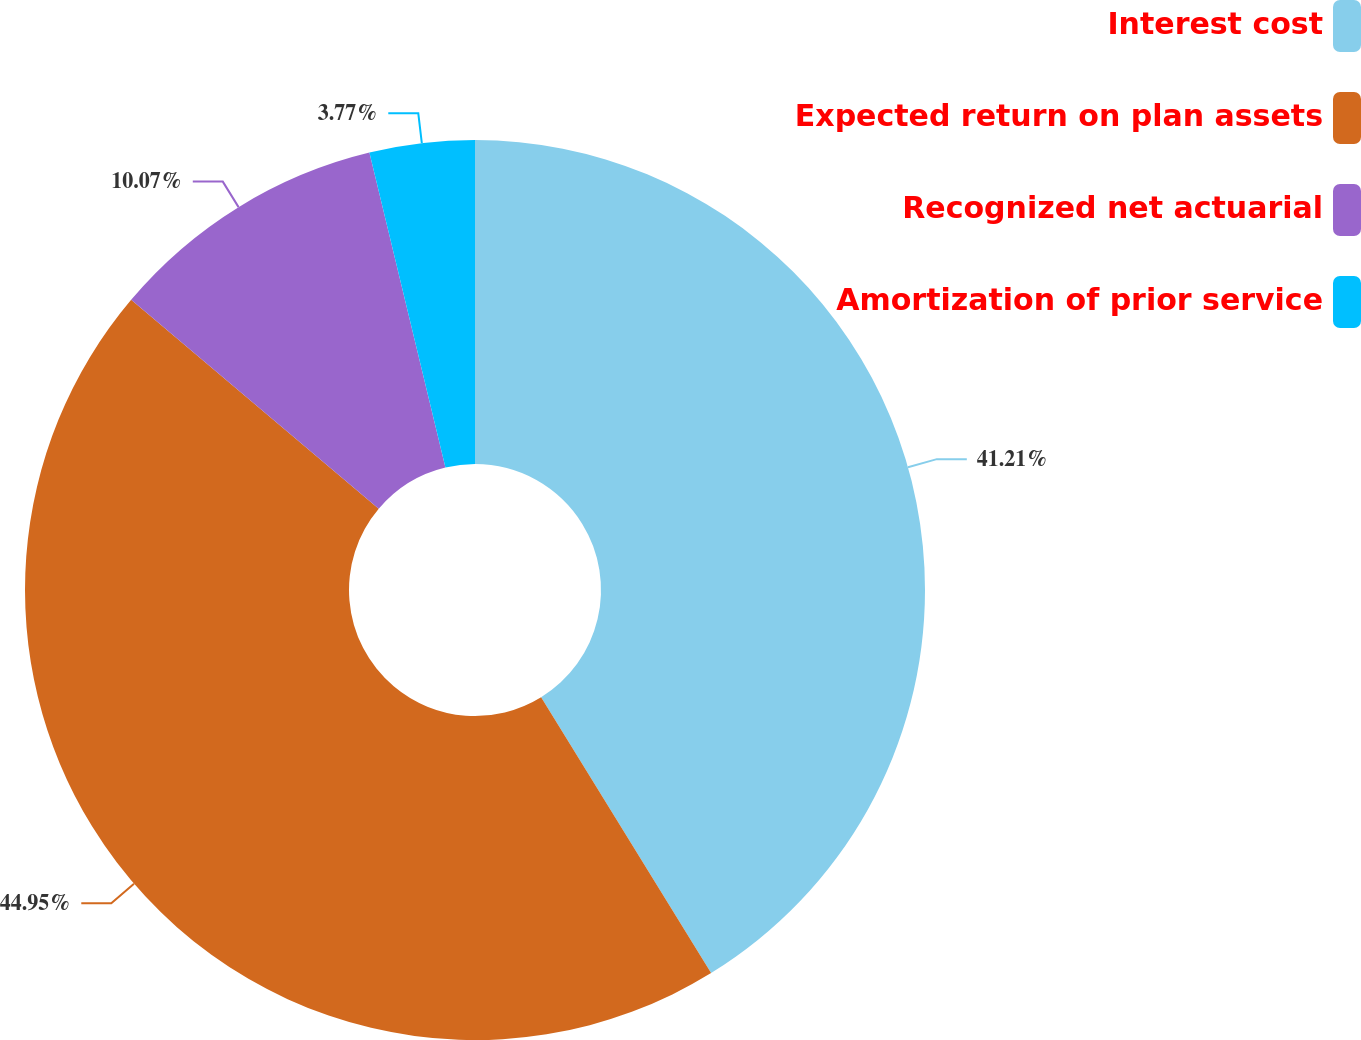Convert chart to OTSL. <chart><loc_0><loc_0><loc_500><loc_500><pie_chart><fcel>Interest cost<fcel>Expected return on plan assets<fcel>Recognized net actuarial<fcel>Amortization of prior service<nl><fcel>41.21%<fcel>44.95%<fcel>10.07%<fcel>3.77%<nl></chart> 